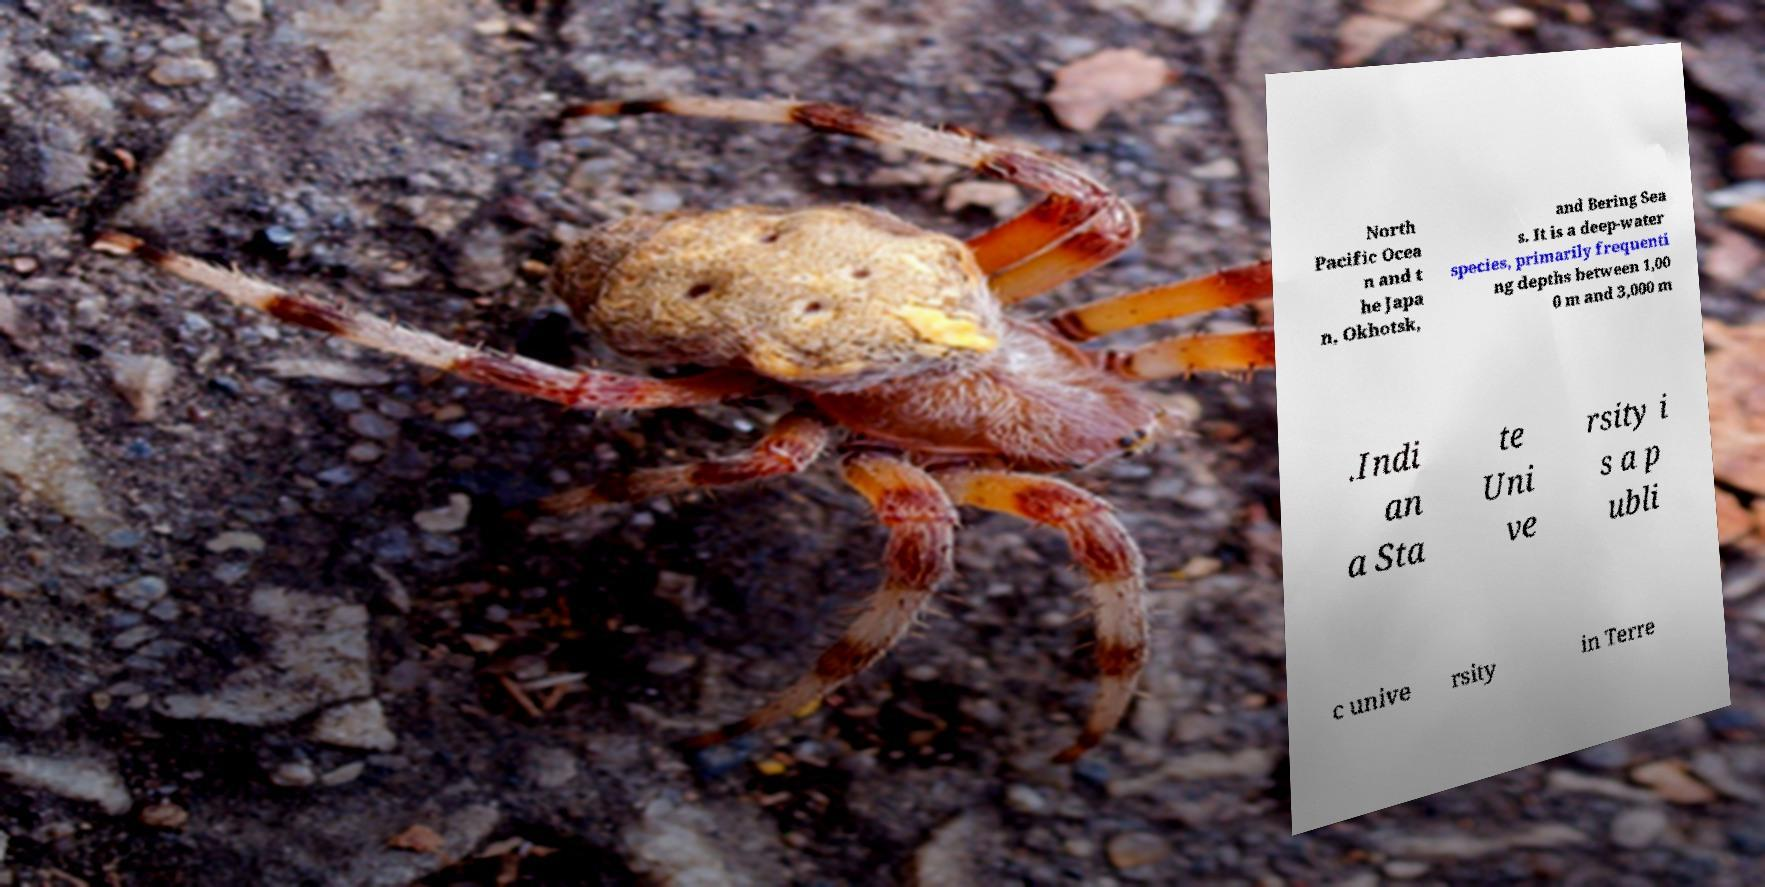Please identify and transcribe the text found in this image. North Pacific Ocea n and t he Japa n, Okhotsk, and Bering Sea s. It is a deep-water species, primarily frequenti ng depths between 1,00 0 m and 3,000 m .Indi an a Sta te Uni ve rsity i s a p ubli c unive rsity in Terre 